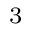<formula> <loc_0><loc_0><loc_500><loc_500>^ { 3 }</formula> 